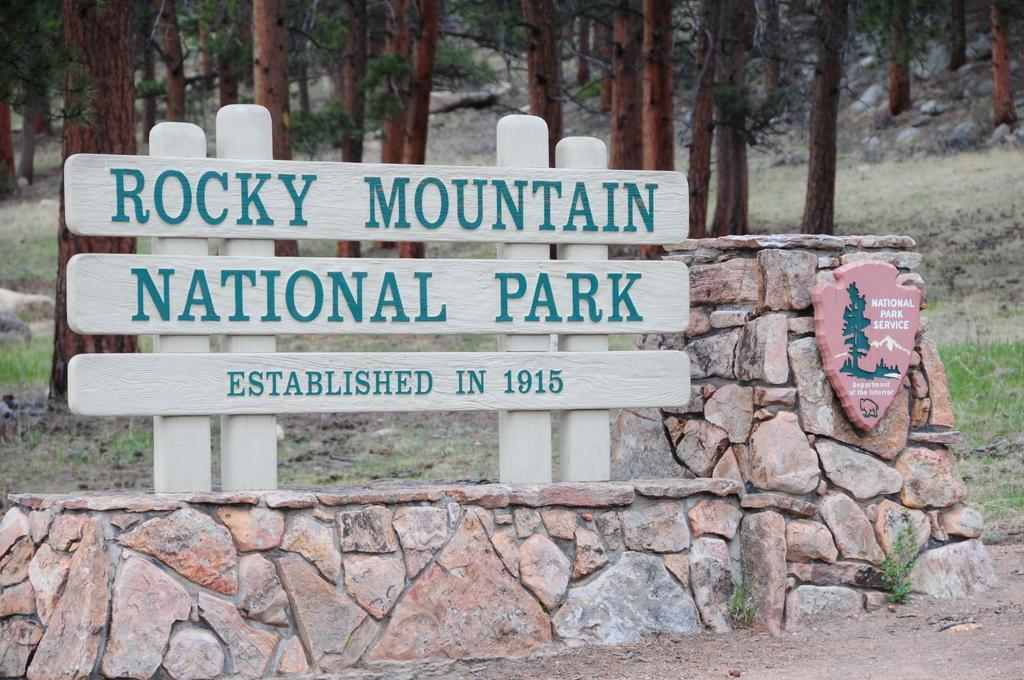Describe this image in one or two sentences. In this image we can see a group of boards with text placed on the poles. On the right side of the image we can see a logo with some text and pictures placed on the stone wall. In the background, we can see grass, stones and group of trees. 